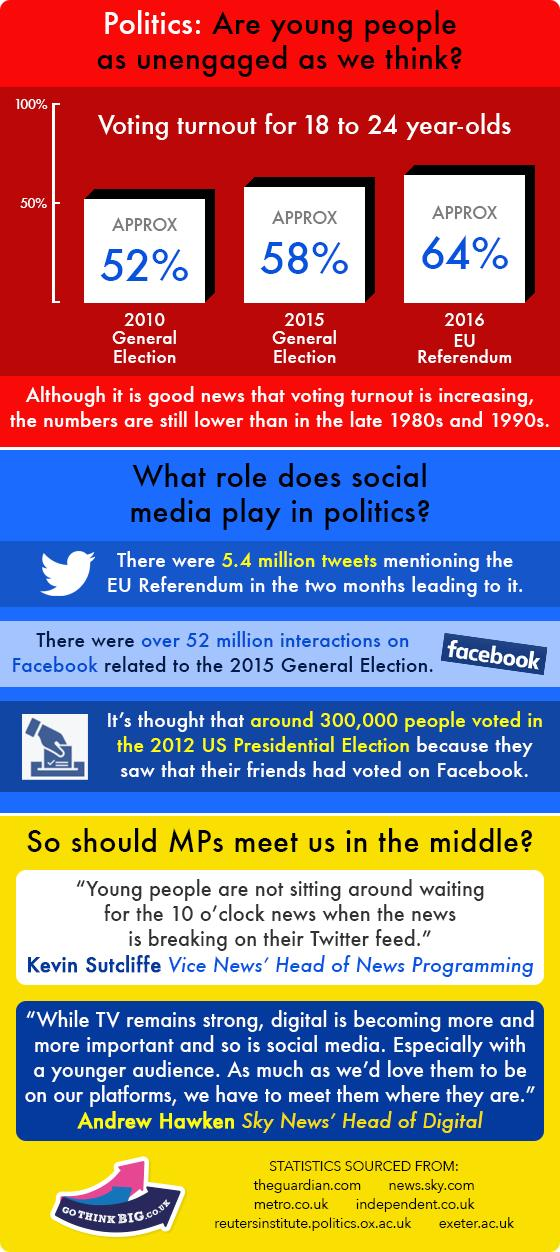Indicate a few pertinent items in this graphic. According to data from the 2015 General Election, the voter turnout among 18-24 year-olds was approximately 58%. 